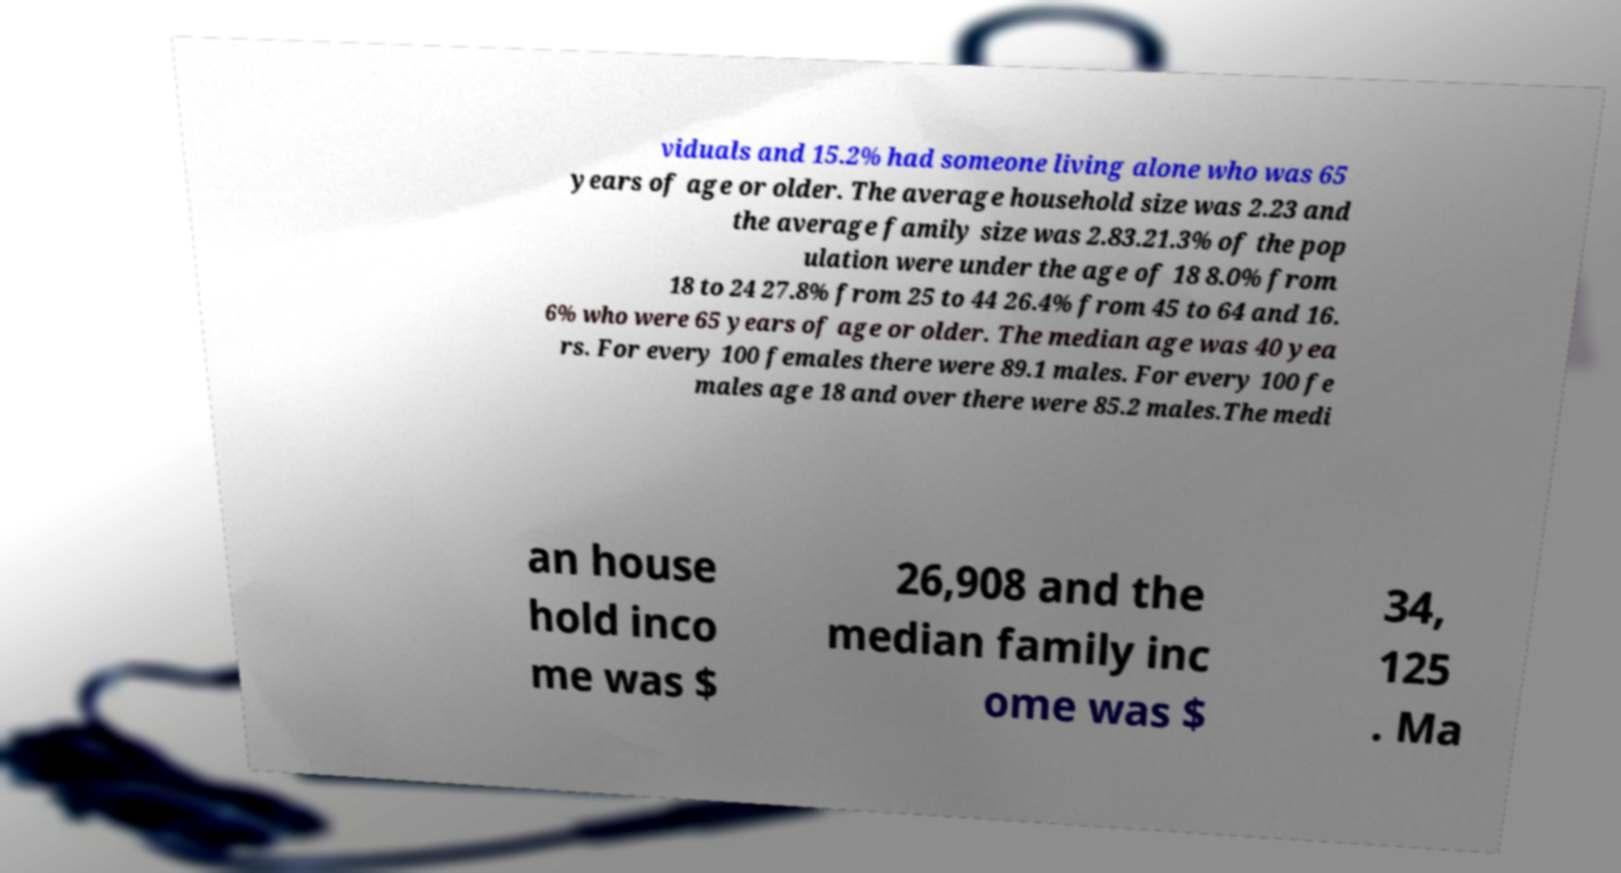Can you accurately transcribe the text from the provided image for me? viduals and 15.2% had someone living alone who was 65 years of age or older. The average household size was 2.23 and the average family size was 2.83.21.3% of the pop ulation were under the age of 18 8.0% from 18 to 24 27.8% from 25 to 44 26.4% from 45 to 64 and 16. 6% who were 65 years of age or older. The median age was 40 yea rs. For every 100 females there were 89.1 males. For every 100 fe males age 18 and over there were 85.2 males.The medi an house hold inco me was $ 26,908 and the median family inc ome was $ 34, 125 . Ma 